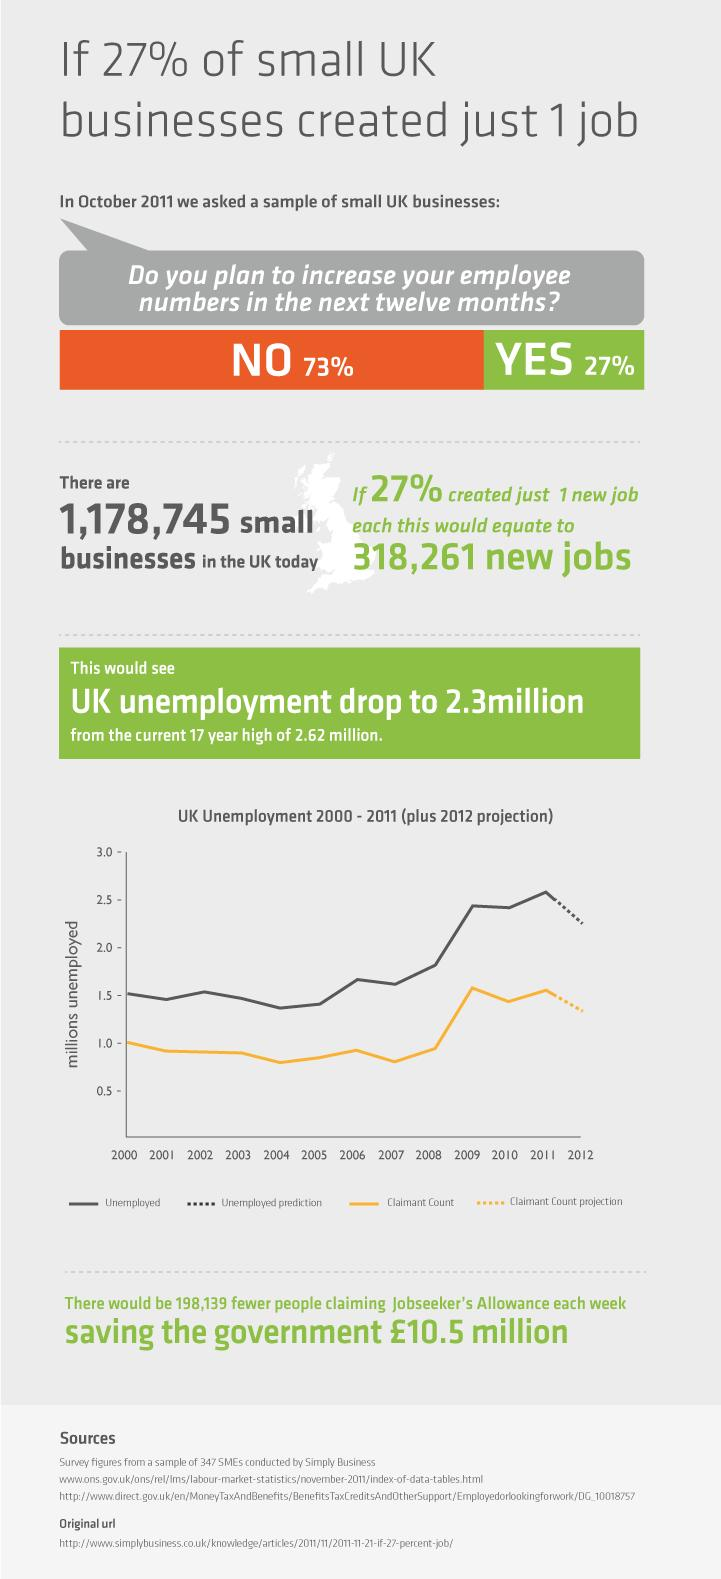Highlight a few significant elements in this photo. According to the survey, 27% of employers were willing to increase their employee numbers. If 27% of the small business firms created one job each, then approximately 318,261 additional jobs would be created. The continuous yellow line plotted on the graph indicates a decrease in the Claimant Count rate over time. There are currently 1,178,745 small businesses operating in the United Kingdom. The color used to represent unemployment on a graph is black. 